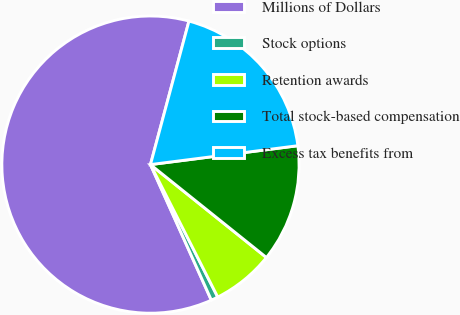Convert chart to OTSL. <chart><loc_0><loc_0><loc_500><loc_500><pie_chart><fcel>Millions of Dollars<fcel>Stock options<fcel>Retention awards<fcel>Total stock-based compensation<fcel>Excess tax benefits from<nl><fcel>60.89%<fcel>0.76%<fcel>6.77%<fcel>12.78%<fcel>18.8%<nl></chart> 